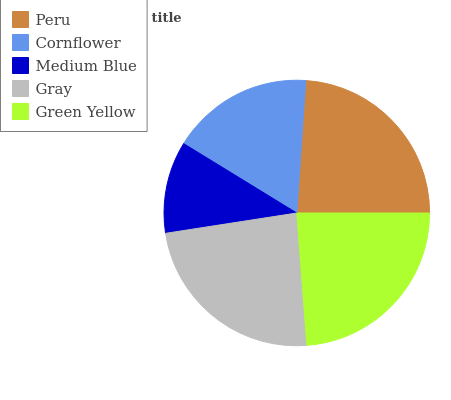Is Medium Blue the minimum?
Answer yes or no. Yes. Is Peru the maximum?
Answer yes or no. Yes. Is Cornflower the minimum?
Answer yes or no. No. Is Cornflower the maximum?
Answer yes or no. No. Is Peru greater than Cornflower?
Answer yes or no. Yes. Is Cornflower less than Peru?
Answer yes or no. Yes. Is Cornflower greater than Peru?
Answer yes or no. No. Is Peru less than Cornflower?
Answer yes or no. No. Is Gray the high median?
Answer yes or no. Yes. Is Gray the low median?
Answer yes or no. Yes. Is Cornflower the high median?
Answer yes or no. No. Is Peru the low median?
Answer yes or no. No. 